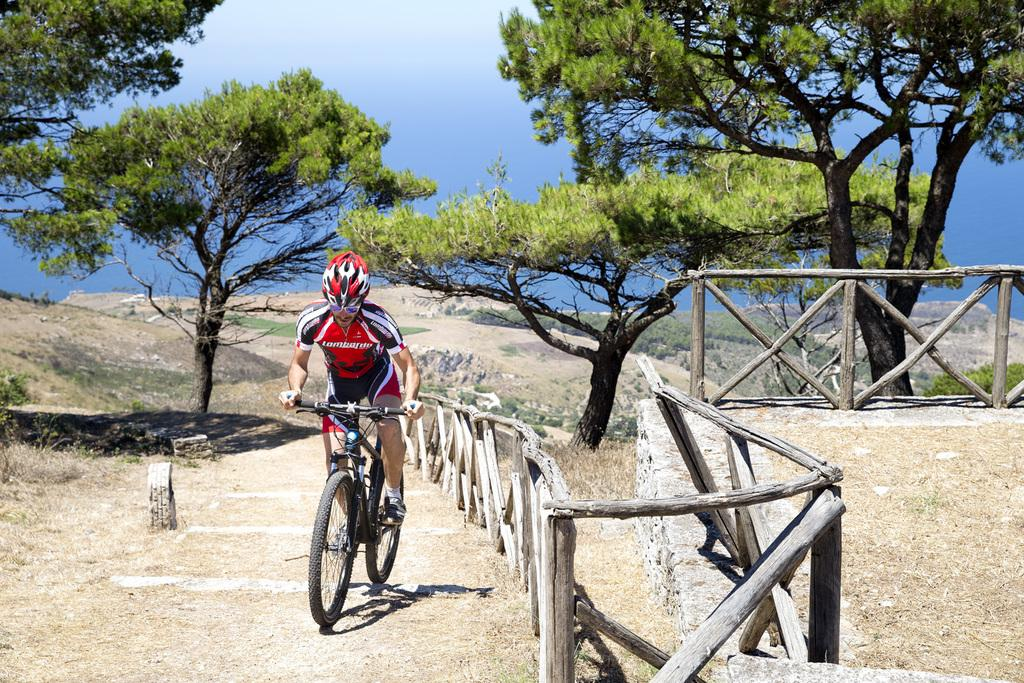What is the man in the image doing? The man is riding a bicycle in the image. What safety precaution is the man taking while riding the bicycle? The man is wearing a helmet. What can be seen in the background of the image? The sky is visible in the background of the image. What type of vegetation is present in the image? There are trees and grass in the image. What architectural feature can be seen in the image? There is a fence in the image. How many bells are hanging from the trees in the image? There are no bells present in the image; it features a man riding a bicycle with a helmet, a fence, trees, grass, and a visible sky. 